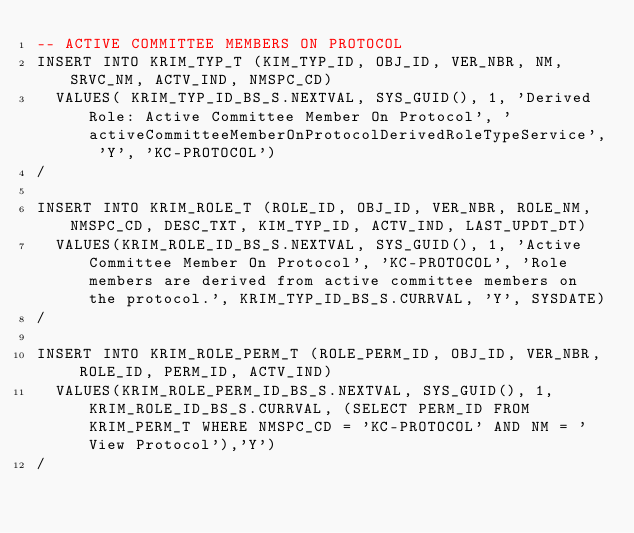Convert code to text. <code><loc_0><loc_0><loc_500><loc_500><_SQL_>-- ACTIVE COMMITTEE MEMBERS ON PROTOCOL
INSERT INTO KRIM_TYP_T (KIM_TYP_ID, OBJ_ID, VER_NBR, NM, SRVC_NM, ACTV_IND, NMSPC_CD)
  VALUES( KRIM_TYP_ID_BS_S.NEXTVAL, SYS_GUID(), 1, 'Derived Role: Active Committee Member On Protocol', 'activeCommitteeMemberOnProtocolDerivedRoleTypeService', 'Y', 'KC-PROTOCOL') 
/

INSERT INTO KRIM_ROLE_T (ROLE_ID, OBJ_ID, VER_NBR, ROLE_NM, NMSPC_CD, DESC_TXT, KIM_TYP_ID, ACTV_IND, LAST_UPDT_DT)
  VALUES(KRIM_ROLE_ID_BS_S.NEXTVAL, SYS_GUID(), 1, 'Active Committee Member On Protocol', 'KC-PROTOCOL', 'Role members are derived from active committee members on the protocol.', KRIM_TYP_ID_BS_S.CURRVAL, 'Y', SYSDATE) 
/

INSERT INTO KRIM_ROLE_PERM_T (ROLE_PERM_ID, OBJ_ID, VER_NBR, ROLE_ID, PERM_ID, ACTV_IND)
  VALUES(KRIM_ROLE_PERM_ID_BS_S.NEXTVAL, SYS_GUID(), 1, KRIM_ROLE_ID_BS_S.CURRVAL, (SELECT PERM_ID FROM KRIM_PERM_T WHERE NMSPC_CD = 'KC-PROTOCOL' AND NM = 'View Protocol'),'Y') 
/
  
   </code> 